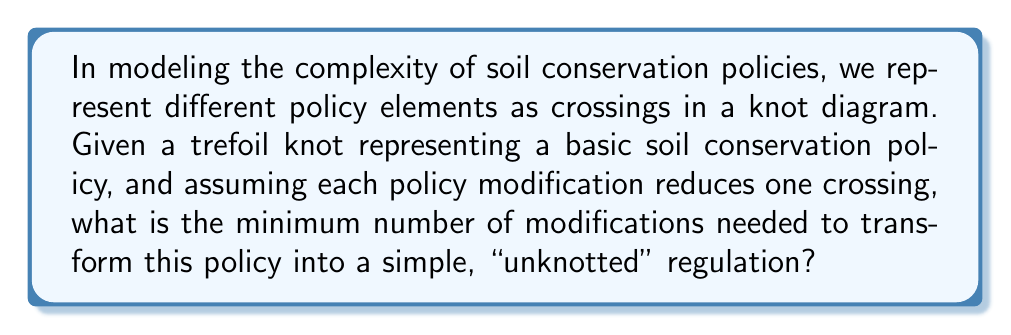Solve this math problem. To solve this problem, we need to understand the concept of unknotting number in knot theory and how it relates to our soil conservation policy model:

1. The trefoil knot is the simplest non-trivial knot, represented as:

[asy]
import graph;
size(100);
draw(Circle((0,0),1));
draw((0.5,0.866)--(0,-1)--(0.5,-0.866)--cycle);
[/asy]

2. The unknotting number of a knot is the minimum number of crossing changes required to transform the knot into the unknot (a simple closed loop with no crossings).

3. For the trefoil knot, it's known that the unknotting number is 1. This means we need to change only one crossing to unknot it.

4. In our policy context:
   - The trefoil knot represents a basic soil conservation policy with three interrelated elements.
   - Each crossing represents a complex interaction between policy elements.
   - Changing a crossing is equivalent to simplifying or modifying a policy interaction.

5. Therefore, the minimum number of modifications needed to transform this policy into a simple, "unknotted" regulation is 1.

This result suggests that even a seemingly complex soil conservation policy (represented by the trefoil knot) can be significantly simplified with a single, well-targeted modification to one of its key interactions.
Answer: 1 